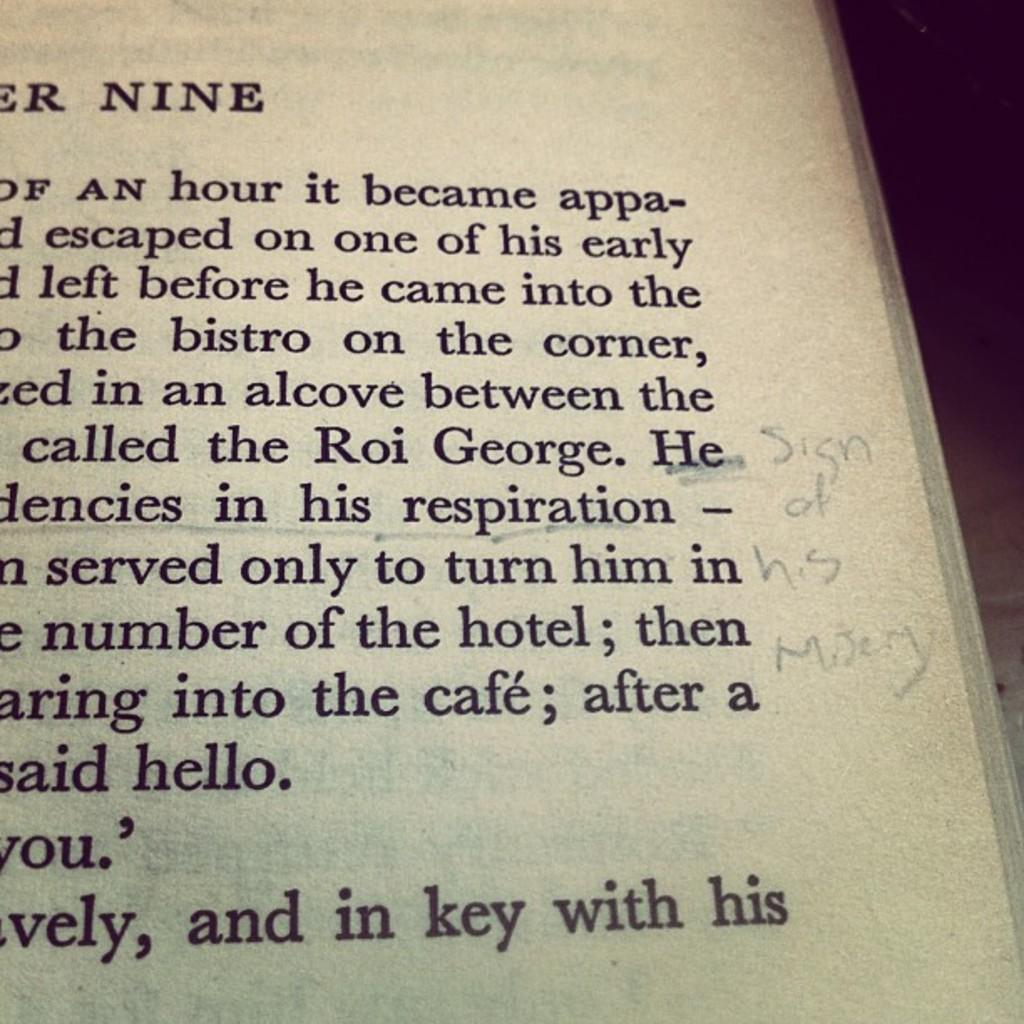<image>
Present a compact description of the photo's key features. the word key is in a book with many words 